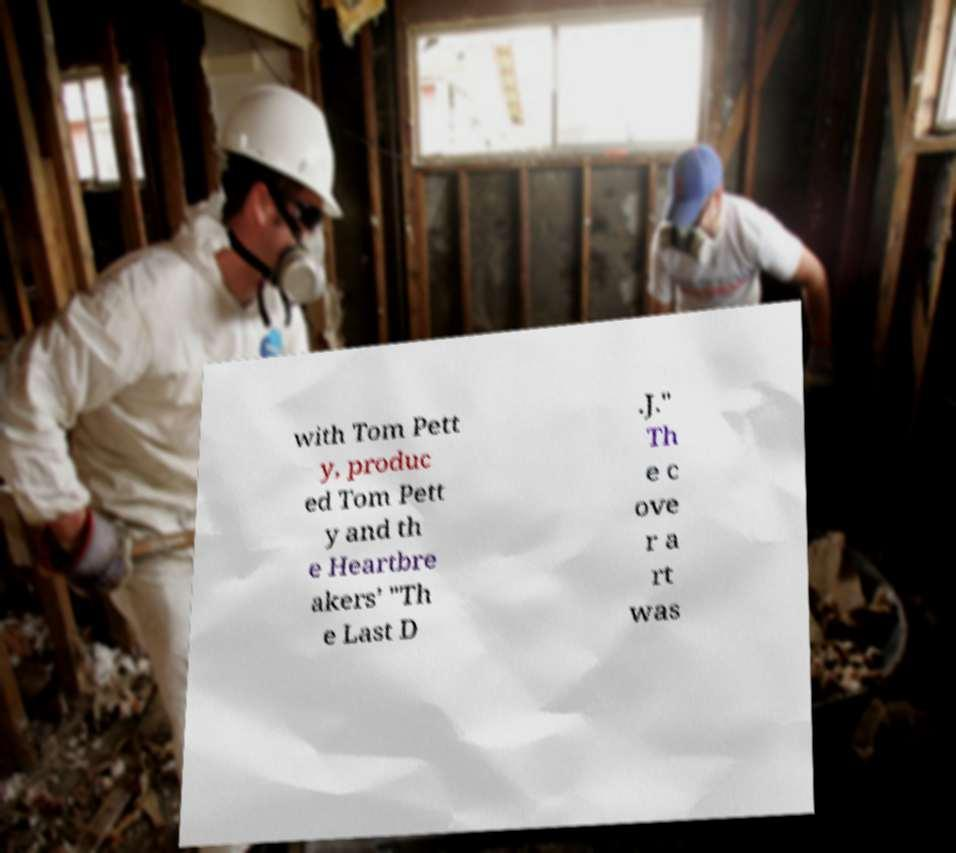Please identify and transcribe the text found in this image. with Tom Pett y, produc ed Tom Pett y and th e Heartbre akers’ "Th e Last D .J." Th e c ove r a rt was 